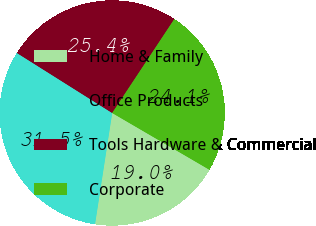Convert chart to OTSL. <chart><loc_0><loc_0><loc_500><loc_500><pie_chart><fcel>Home & Family<fcel>Office Products<fcel>Tools Hardware & Commercial<fcel>Corporate<nl><fcel>19.03%<fcel>31.51%<fcel>25.36%<fcel>24.11%<nl></chart> 